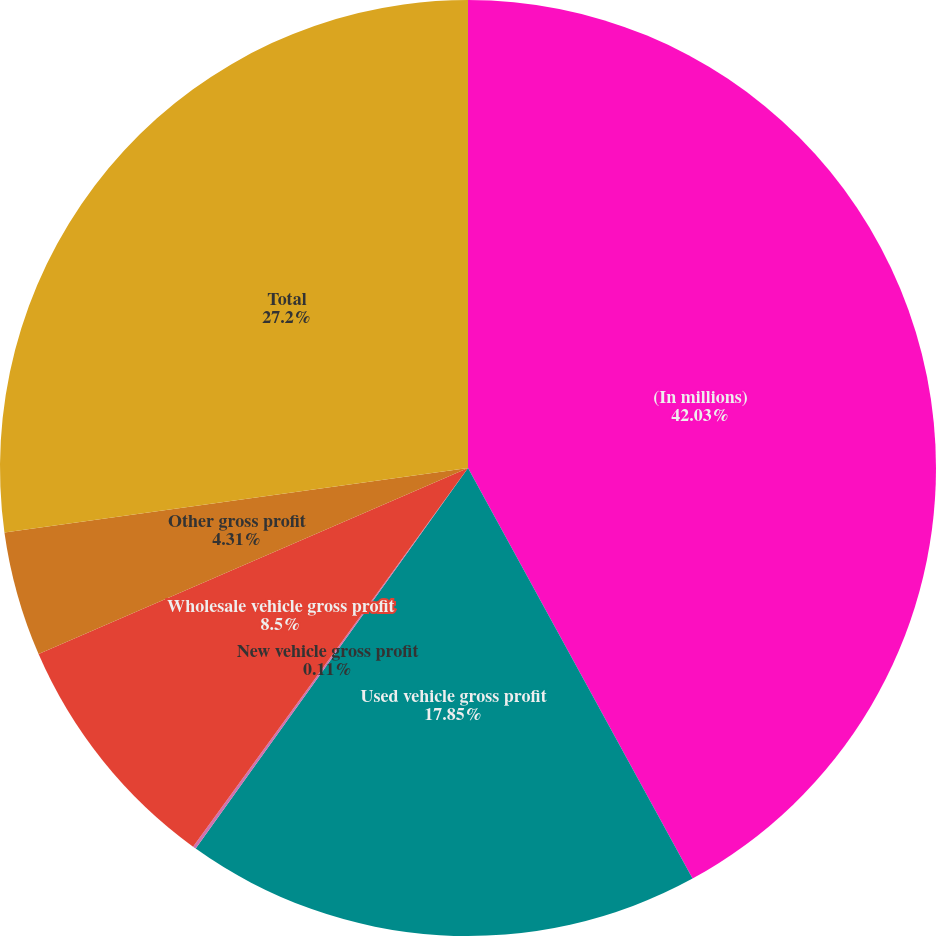Convert chart to OTSL. <chart><loc_0><loc_0><loc_500><loc_500><pie_chart><fcel>(In millions)<fcel>Used vehicle gross profit<fcel>New vehicle gross profit<fcel>Wholesale vehicle gross profit<fcel>Other gross profit<fcel>Total<nl><fcel>42.04%<fcel>17.85%<fcel>0.11%<fcel>8.5%<fcel>4.31%<fcel>27.2%<nl></chart> 